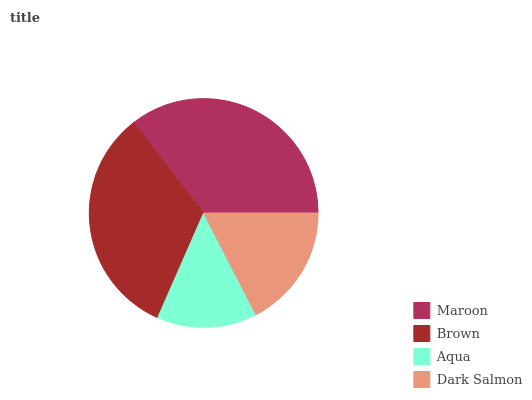Is Aqua the minimum?
Answer yes or no. Yes. Is Maroon the maximum?
Answer yes or no. Yes. Is Brown the minimum?
Answer yes or no. No. Is Brown the maximum?
Answer yes or no. No. Is Maroon greater than Brown?
Answer yes or no. Yes. Is Brown less than Maroon?
Answer yes or no. Yes. Is Brown greater than Maroon?
Answer yes or no. No. Is Maroon less than Brown?
Answer yes or no. No. Is Brown the high median?
Answer yes or no. Yes. Is Dark Salmon the low median?
Answer yes or no. Yes. Is Aqua the high median?
Answer yes or no. No. Is Aqua the low median?
Answer yes or no. No. 